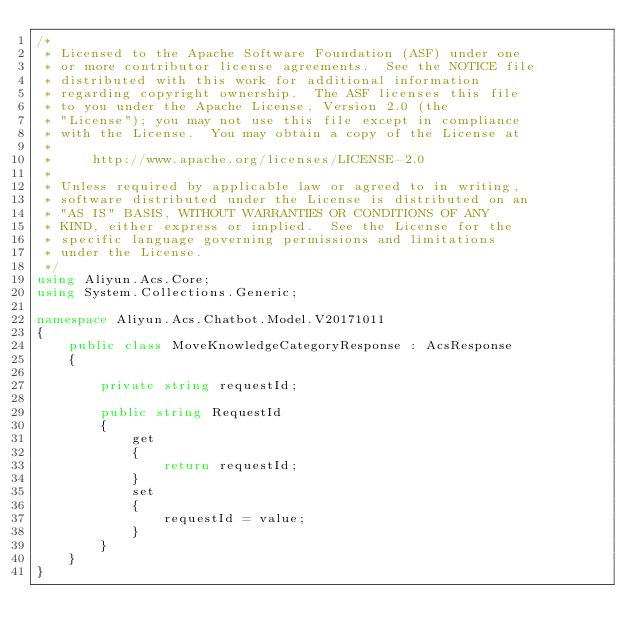<code> <loc_0><loc_0><loc_500><loc_500><_C#_>/*
 * Licensed to the Apache Software Foundation (ASF) under one
 * or more contributor license agreements.  See the NOTICE file
 * distributed with this work for additional information
 * regarding copyright ownership.  The ASF licenses this file
 * to you under the Apache License, Version 2.0 (the
 * "License"); you may not use this file except in compliance
 * with the License.  You may obtain a copy of the License at
 *
 *     http://www.apache.org/licenses/LICENSE-2.0
 *
 * Unless required by applicable law or agreed to in writing,
 * software distributed under the License is distributed on an
 * "AS IS" BASIS, WITHOUT WARRANTIES OR CONDITIONS OF ANY
 * KIND, either express or implied.  See the License for the
 * specific language governing permissions and limitations
 * under the License.
 */
using Aliyun.Acs.Core;
using System.Collections.Generic;

namespace Aliyun.Acs.Chatbot.Model.V20171011
{
	public class MoveKnowledgeCategoryResponse : AcsResponse
	{

		private string requestId;

		public string RequestId
		{
			get
			{
				return requestId;
			}
			set	
			{
				requestId = value;
			}
		}
	}
}</code> 